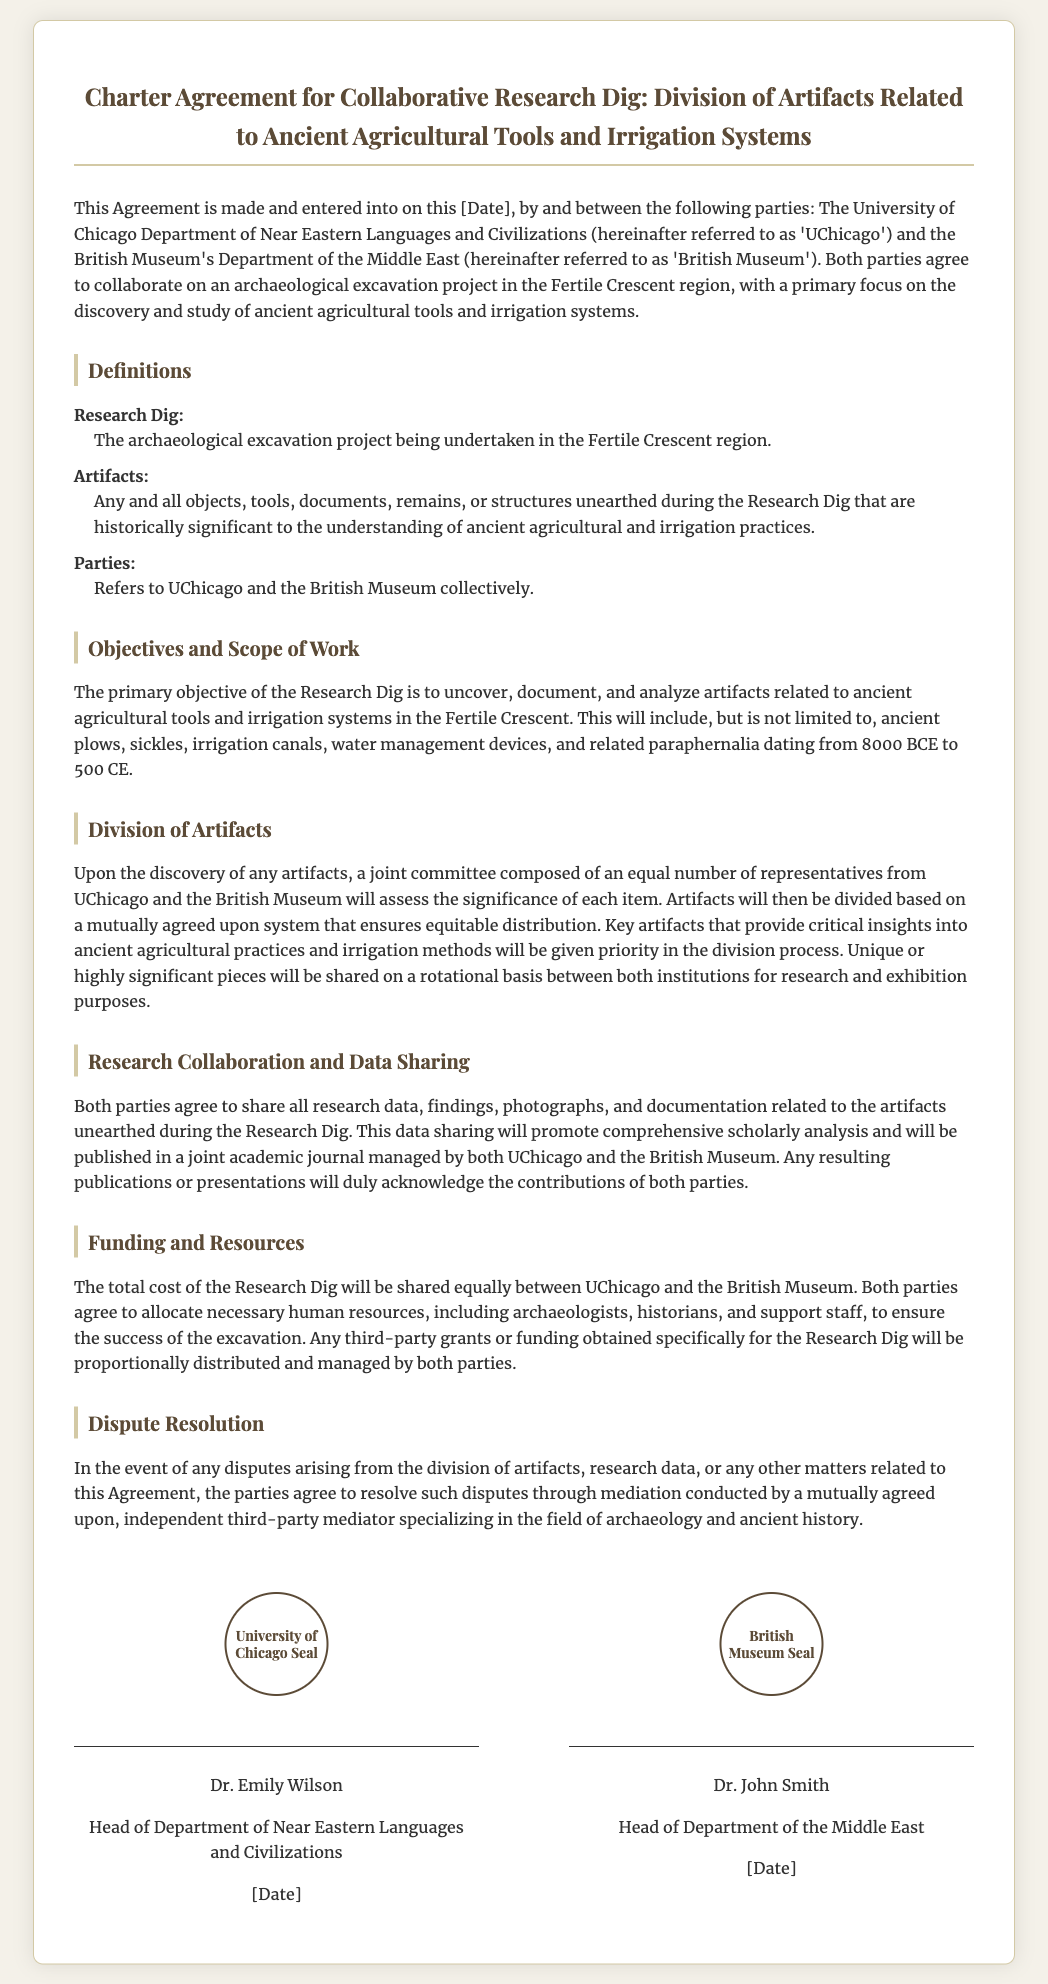what is the title of the document? The title of the document presents the purpose and subject matter of the agreement.
Answer: Charter Agreement for Collaborative Research Dig: Division of Artifacts Related to Ancient Agricultural Tools and Irrigation Systems who are the parties involved in the agreement? The agreement identifies the two parties that are collaborating on the research dig.
Answer: UChicago and the British Museum what is the primary focus of the Research Dig? The document outlines the main objective of the archaeological excavation project.
Answer: discovery and study of ancient agricultural tools and irrigation systems what year range do the artifacts of interest date back to? The document specifies the time period relevant to the archaeological findings sought in the dig.
Answer: 8000 BCE to 500 CE how will artifacts be divided after discovery? The procedure for assessing and distributing the artifacts is described in the document.
Answer: through a joint committee what will be the basis for resolving any disputes? The agreement includes a section that defines how conflicts will be addressed between the parties.
Answer: mediation who is the head of the Department of Near Eastern Languages and Civilizations? The document contains signatures from key individuals representing both parties.
Answer: Dr. Emily Wilson when was the agreement made? The document states a placeholder for the date of the agreement.
Answer: [Date] 